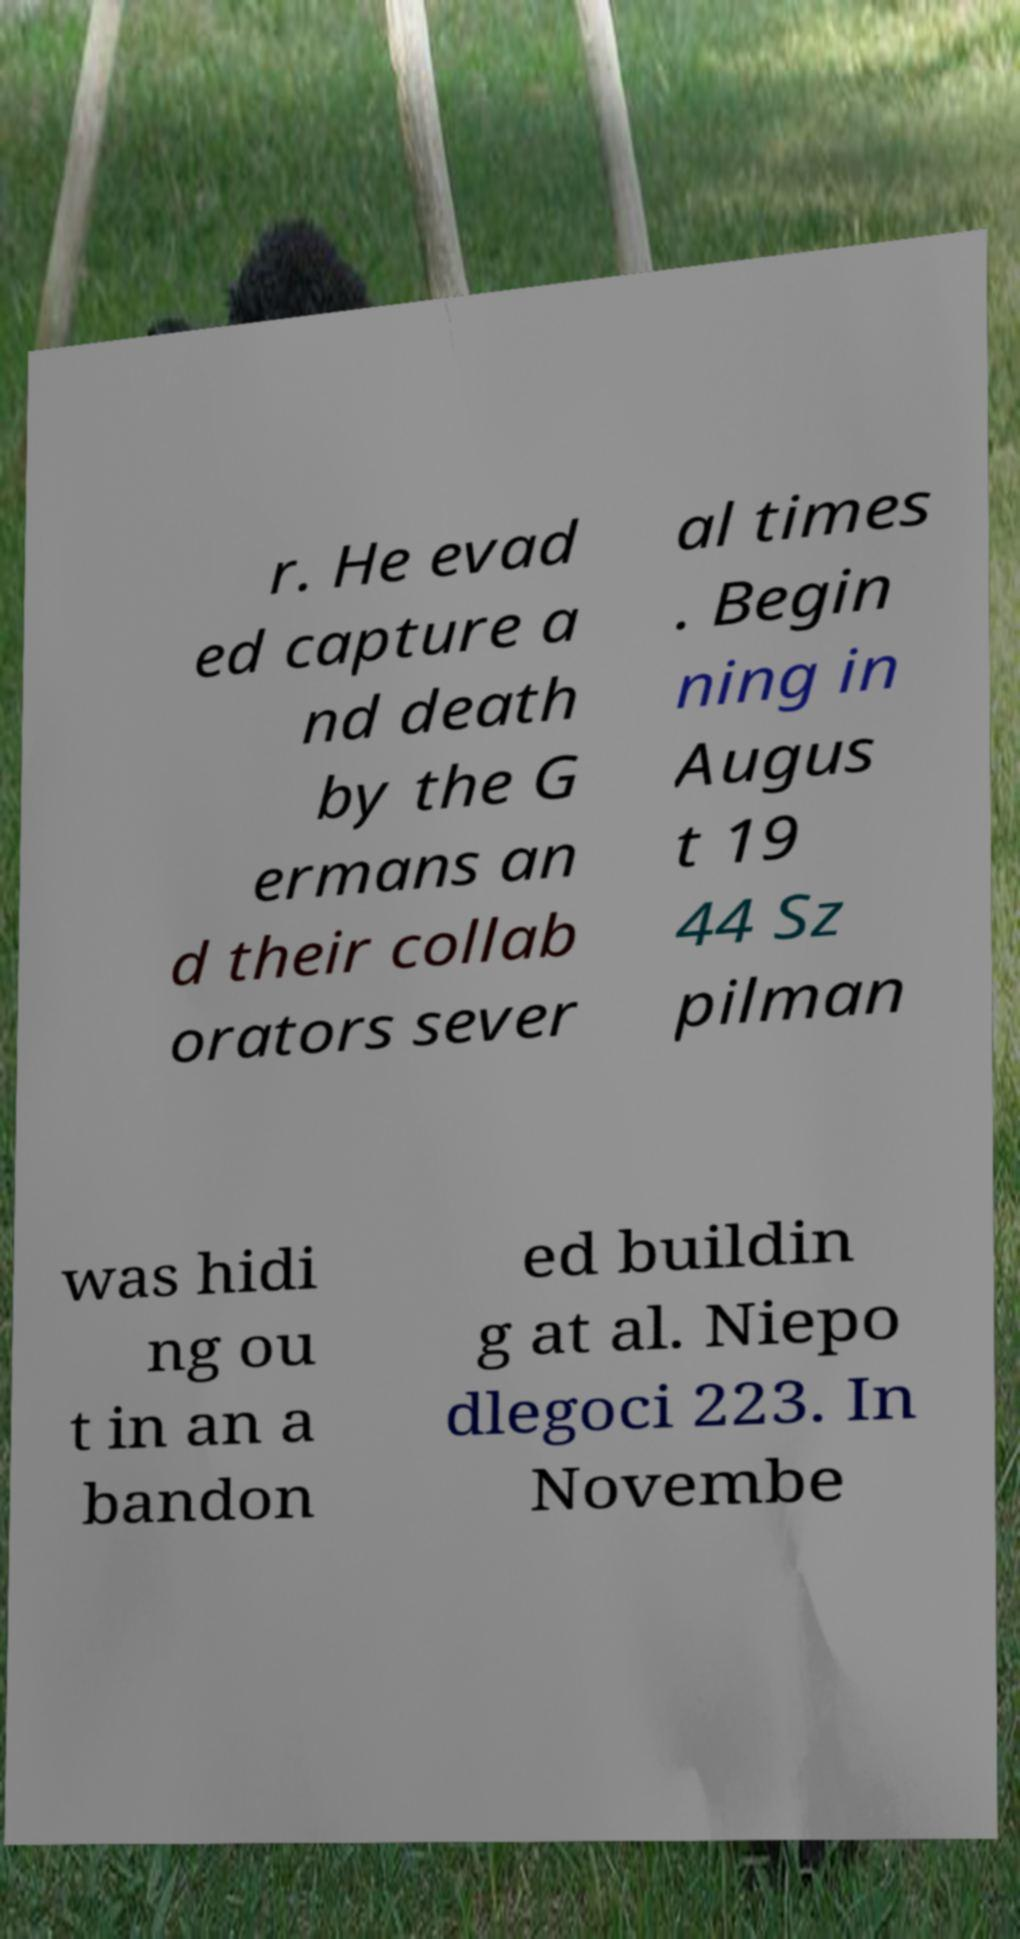Could you extract and type out the text from this image? r. He evad ed capture a nd death by the G ermans an d their collab orators sever al times . Begin ning in Augus t 19 44 Sz pilman was hidi ng ou t in an a bandon ed buildin g at al. Niepo dlegoci 223. In Novembe 